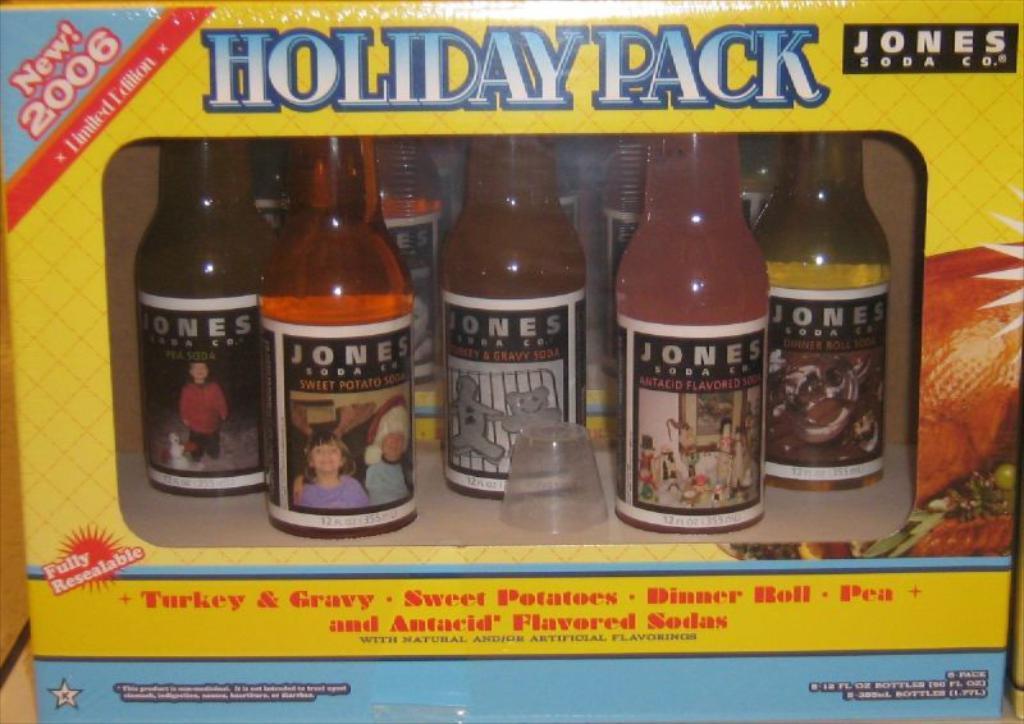How would you summarize this image in a sentence or two? In this picture we can see a bottles with stickers to it and different kinds of drinks in it and a cap and this are placed in a wooden box with some poster on it. 